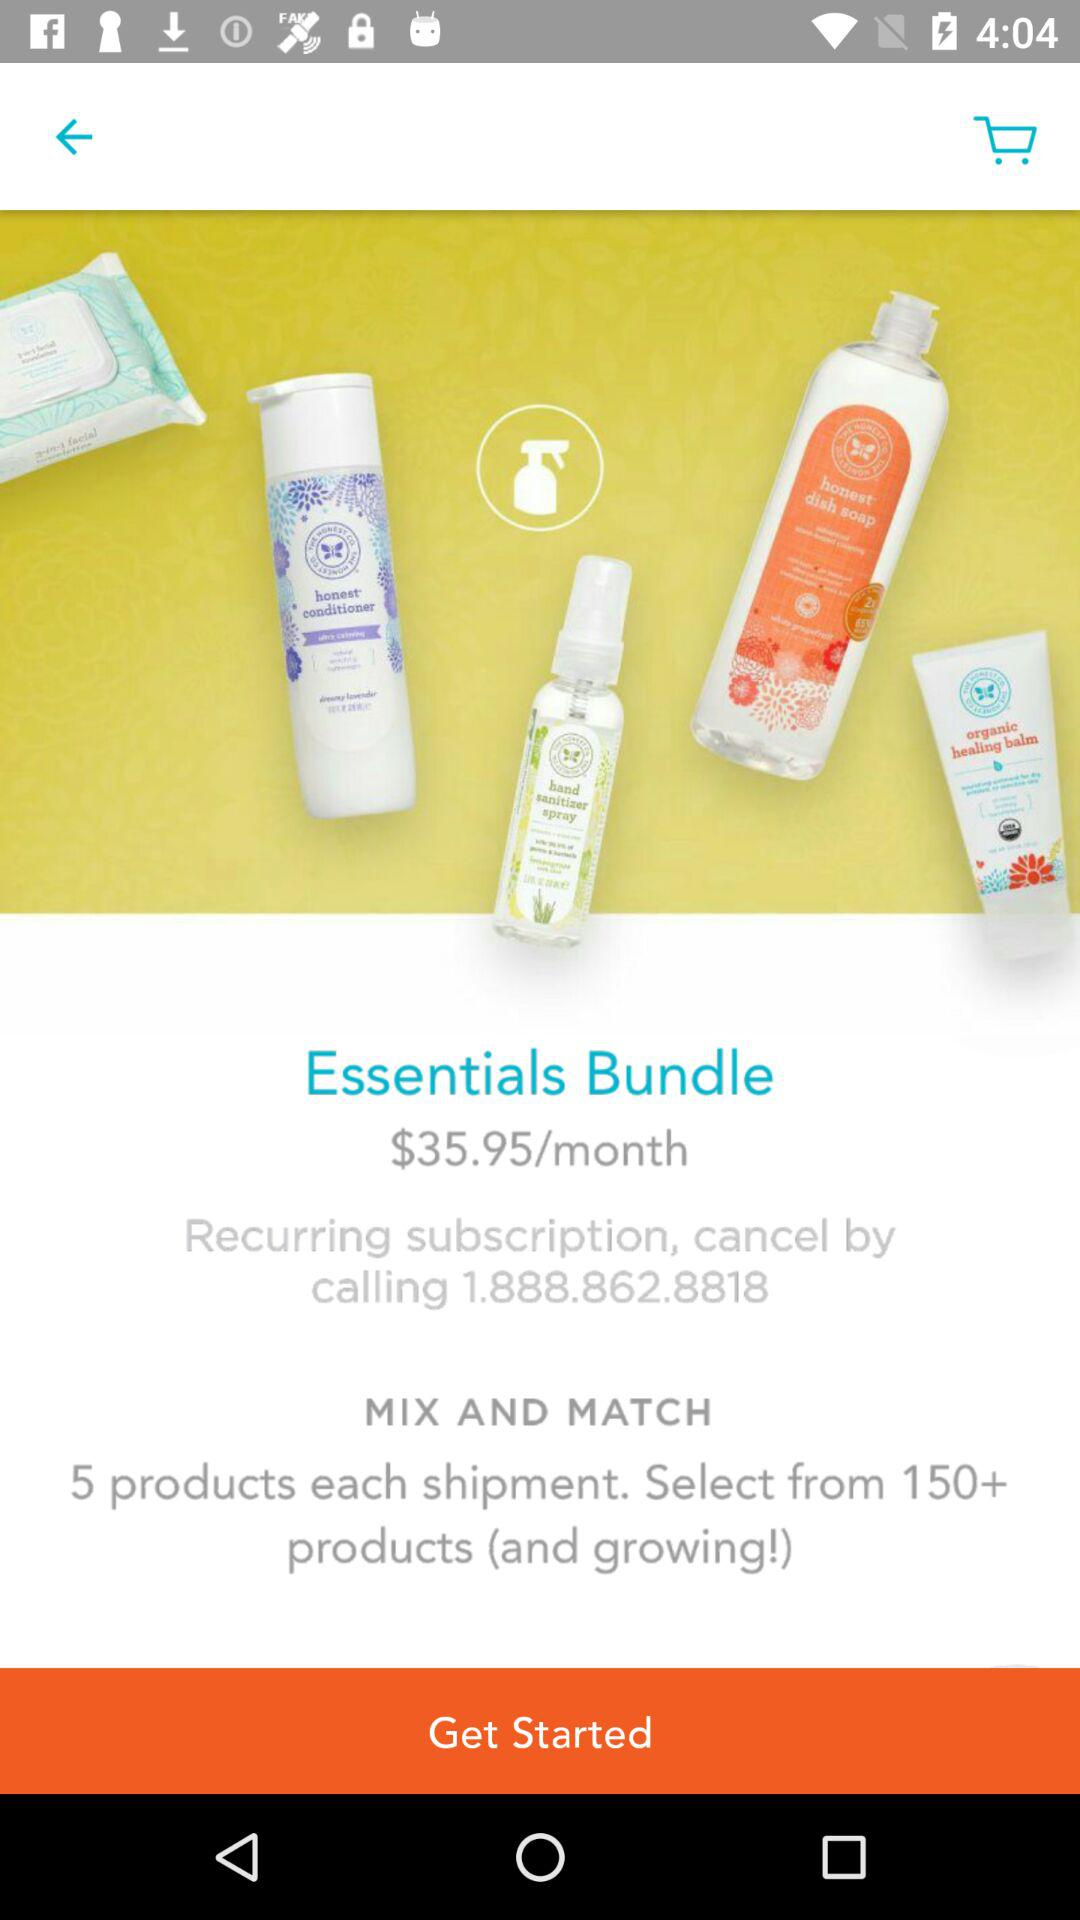What is the price per month of the essentials bundle? The price per month is $35.95. 